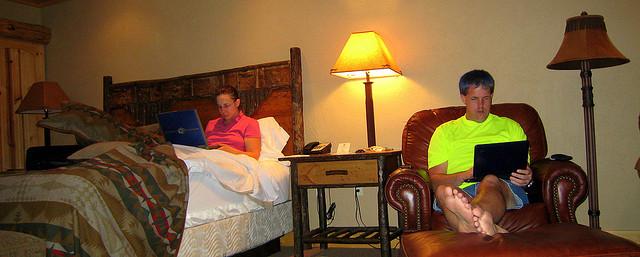How many people are in the room?
Write a very short answer. 2. Are all lamps on?
Quick response, please. No. What are they doing?
Answer briefly. Reading. Are these people communicating?
Write a very short answer. No. 